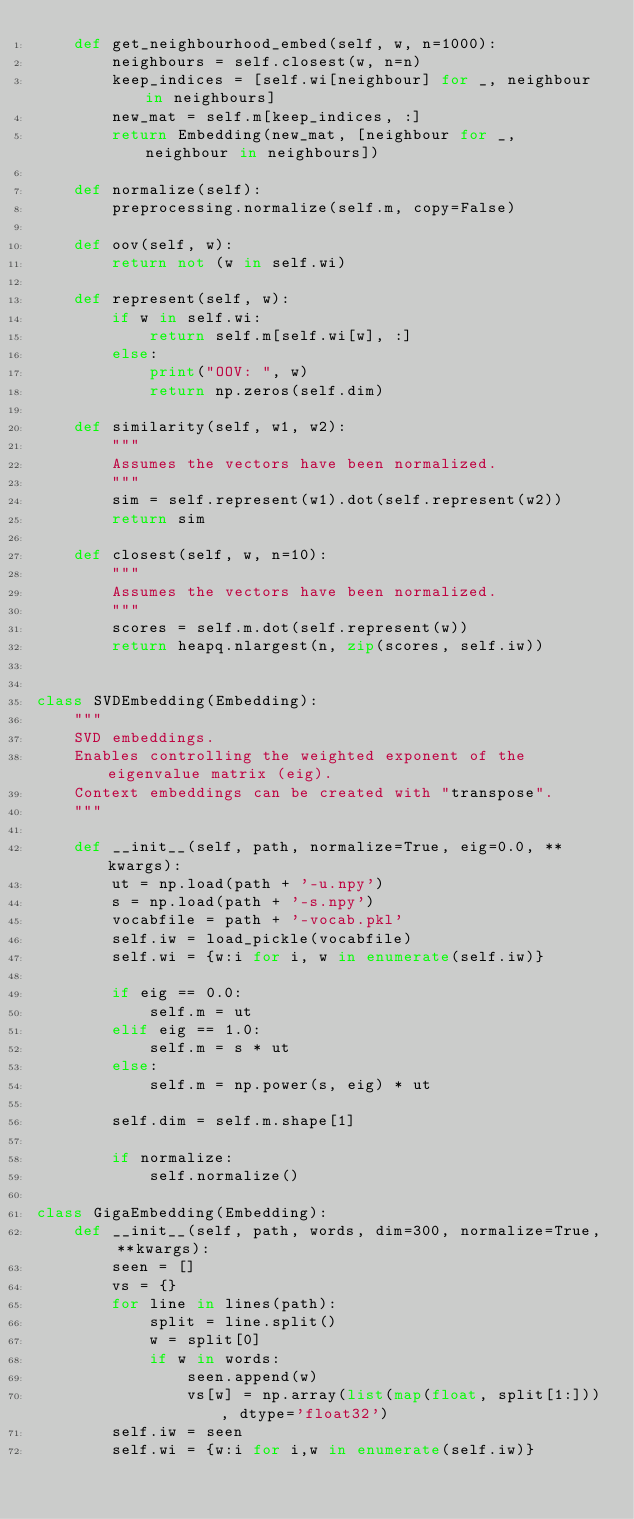<code> <loc_0><loc_0><loc_500><loc_500><_Python_>    def get_neighbourhood_embed(self, w, n=1000):
        neighbours = self.closest(w, n=n)
        keep_indices = [self.wi[neighbour] for _, neighbour in neighbours] 
        new_mat = self.m[keep_indices, :]
        return Embedding(new_mat, [neighbour for _, neighbour in neighbours]) 

    def normalize(self):
        preprocessing.normalize(self.m, copy=False)

    def oov(self, w):
        return not (w in self.wi)

    def represent(self, w):
        if w in self.wi:
            return self.m[self.wi[w], :]
        else:
            print("OOV: ", w)
            return np.zeros(self.dim)

    def similarity(self, w1, w2):
        """
        Assumes the vectors have been normalized.
        """
        sim = self.represent(w1).dot(self.represent(w2))
        return sim

    def closest(self, w, n=10):
        """
        Assumes the vectors have been normalized.
        """
        scores = self.m.dot(self.represent(w))
        return heapq.nlargest(n, zip(scores, self.iw))
    

class SVDEmbedding(Embedding):
    """
    SVD embeddings.
    Enables controlling the weighted exponent of the eigenvalue matrix (eig).
    Context embeddings can be created with "transpose".
    """
    
    def __init__(self, path, normalize=True, eig=0.0, **kwargs):
        ut = np.load(path + '-u.npy')
        s = np.load(path + '-s.npy')
        vocabfile = path + '-vocab.pkl'
        self.iw = load_pickle(vocabfile)
        self.wi = {w:i for i, w in enumerate(self.iw)}
 
        if eig == 0.0:
            self.m = ut
        elif eig == 1.0:
            self.m = s * ut
        else:
            self.m = np.power(s, eig) * ut

        self.dim = self.m.shape[1]

        if normalize:
            self.normalize()

class GigaEmbedding(Embedding):
    def __init__(self, path, words, dim=300, normalize=True, **kwargs):
        seen = []
        vs = {}
        for line in lines(path):
            split = line.split()
            w = split[0]
            if w in words:
                seen.append(w)
                vs[w] = np.array(list(map(float, split[1:])), dtype='float32')
        self.iw = seen
        self.wi = {w:i for i,w in enumerate(self.iw)}</code> 